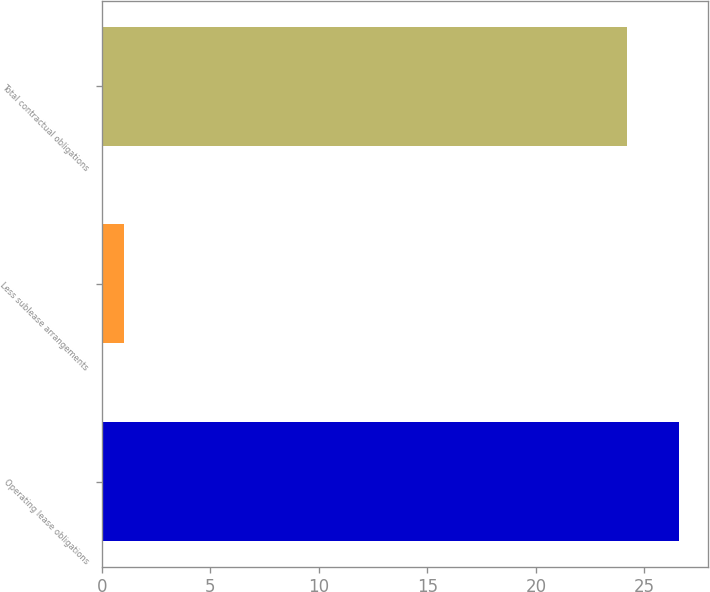Convert chart to OTSL. <chart><loc_0><loc_0><loc_500><loc_500><bar_chart><fcel>Operating lease obligations<fcel>Less sublease arrangements<fcel>Total contractual obligations<nl><fcel>26.62<fcel>1<fcel>24.2<nl></chart> 